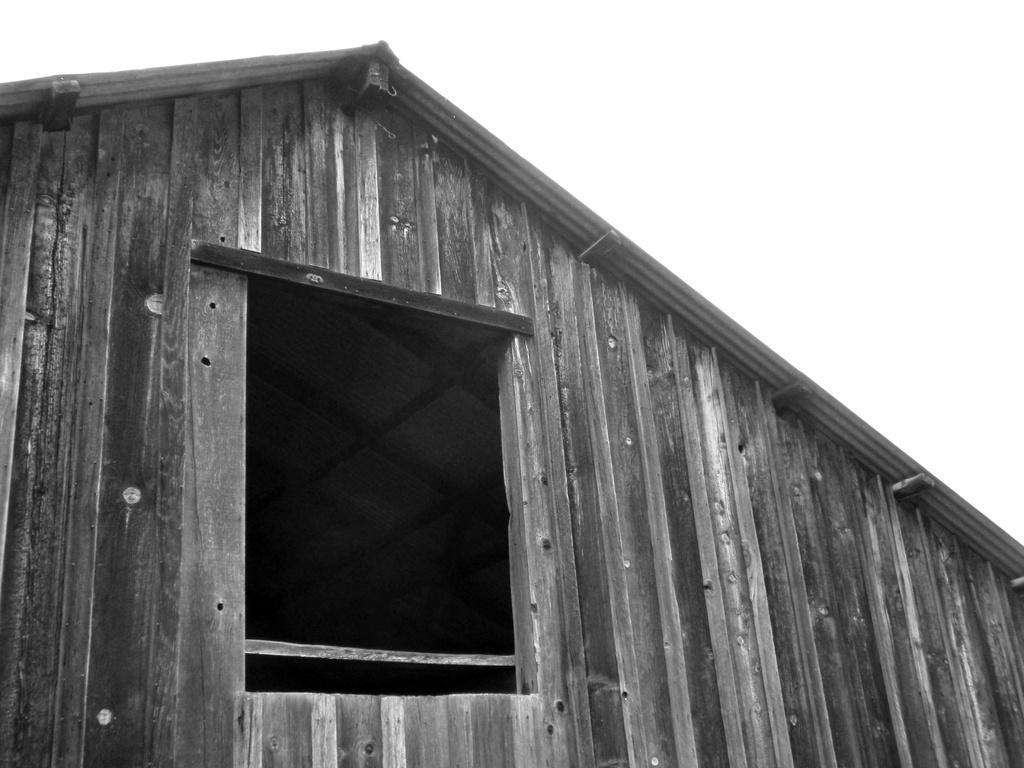What is the color scheme of the image? The image is black and white. What is the main subject in the image? There is a building in the image. What material is used for the wall of the building? The building has a wooden wall. What feature can be seen in the wooden wall? There is a square hole in the wall. What color is the background of the image? The background of the image is white. What type of power source is visible in the image? There is no power source visible in the image; it is a black and white image of a building with a wooden wall and a square hole. Can you see a train passing by in the image? There is no train present in the image. 